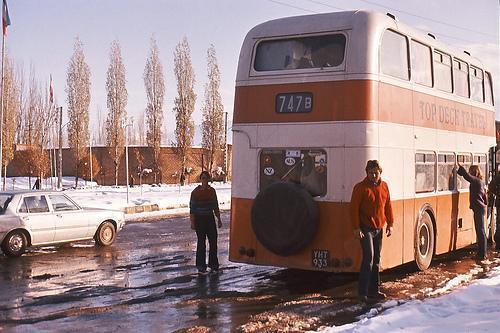How many busses are there?
Give a very brief answer. 1. 